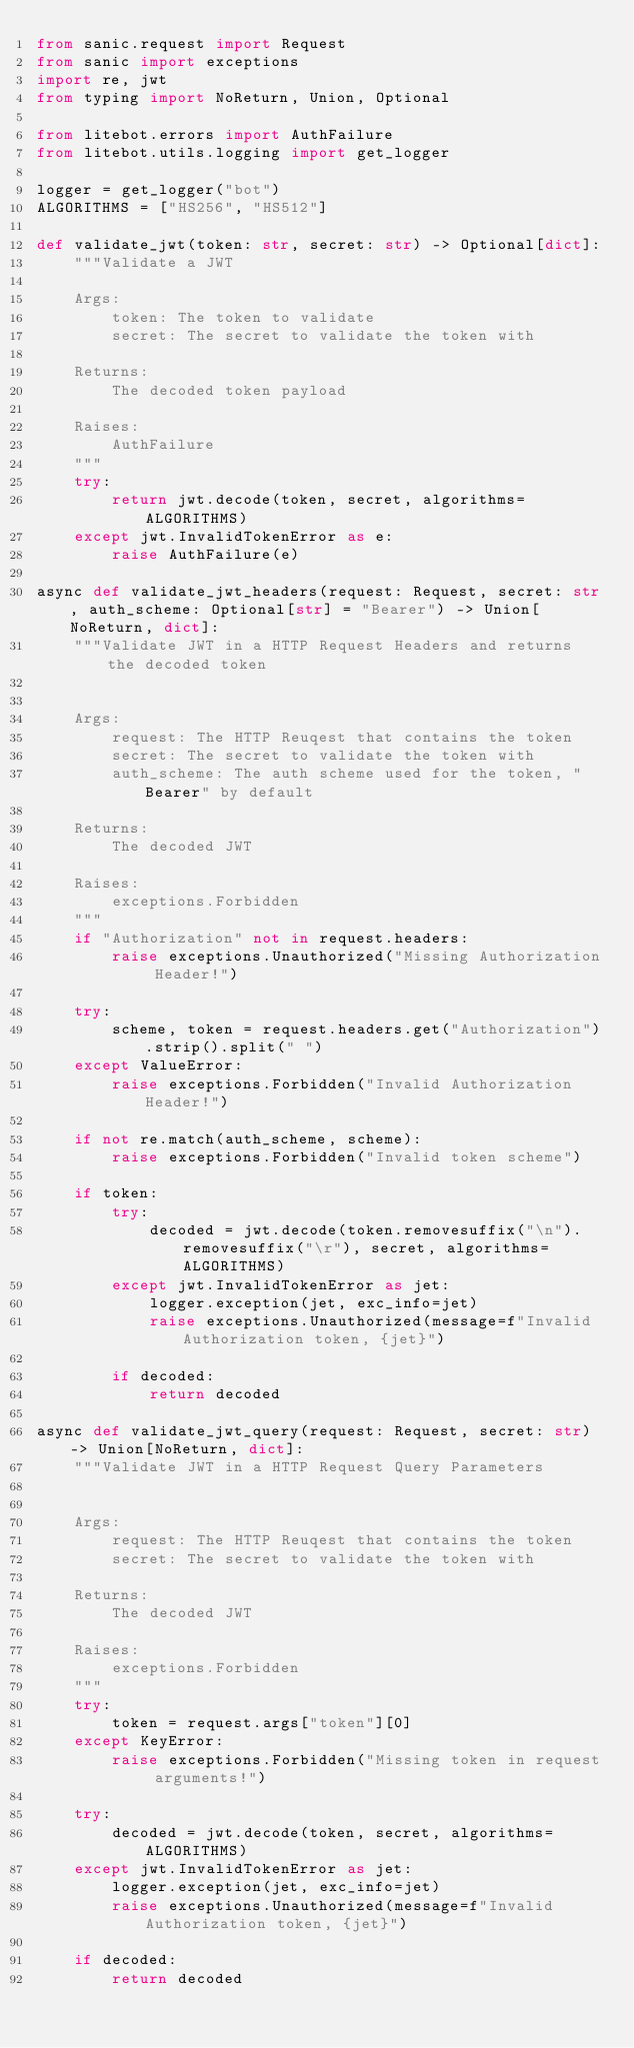Convert code to text. <code><loc_0><loc_0><loc_500><loc_500><_Python_>from sanic.request import Request
from sanic import exceptions
import re, jwt
from typing import NoReturn, Union, Optional

from litebot.errors import AuthFailure
from litebot.utils.logging import get_logger

logger = get_logger("bot")
ALGORITHMS = ["HS256", "HS512"]

def validate_jwt(token: str, secret: str) -> Optional[dict]:
    """Validate a JWT

    Args:
        token: The token to validate
        secret: The secret to validate the token with

    Returns:
        The decoded token payload

    Raises:
        AuthFailure
    """
    try:
        return jwt.decode(token, secret, algorithms=ALGORITHMS)
    except jwt.InvalidTokenError as e:
        raise AuthFailure(e)

async def validate_jwt_headers(request: Request, secret: str, auth_scheme: Optional[str] = "Bearer") -> Union[NoReturn, dict]:
    """Validate JWT in a HTTP Request Headers and returns the decoded token


    Args:
        request: The HTTP Reuqest that contains the token
        secret: The secret to validate the token with
        auth_scheme: The auth scheme used for the token, "Bearer" by default

    Returns:
        The decoded JWT

    Raises:
        exceptions.Forbidden
    """
    if "Authorization" not in request.headers:
        raise exceptions.Unauthorized("Missing Authorization Header!")

    try:
        scheme, token = request.headers.get("Authorization").strip().split(" ")
    except ValueError:
        raise exceptions.Forbidden("Invalid Authorization Header!")

    if not re.match(auth_scheme, scheme):
        raise exceptions.Forbidden("Invalid token scheme")

    if token:
        try:
            decoded = jwt.decode(token.removesuffix("\n").removesuffix("\r"), secret, algorithms=ALGORITHMS)
        except jwt.InvalidTokenError as jet:
            logger.exception(jet, exc_info=jet)
            raise exceptions.Unauthorized(message=f"Invalid Authorization token, {jet}")

        if decoded:
            return decoded

async def validate_jwt_query(request: Request, secret: str) -> Union[NoReturn, dict]:
    """Validate JWT in a HTTP Request Query Parameters


    Args:
        request: The HTTP Reuqest that contains the token
        secret: The secret to validate the token with

    Returns:
        The decoded JWT

    Raises:
        exceptions.Forbidden
    """
    try:
        token = request.args["token"][0]
    except KeyError:
        raise exceptions.Forbidden("Missing token in request arguments!")

    try:
        decoded = jwt.decode(token, secret, algorithms=ALGORITHMS)
    except jwt.InvalidTokenError as jet:
        logger.exception(jet, exc_info=jet)
        raise exceptions.Unauthorized(message=f"Invalid Authorization token, {jet}")

    if decoded:
        return decoded</code> 